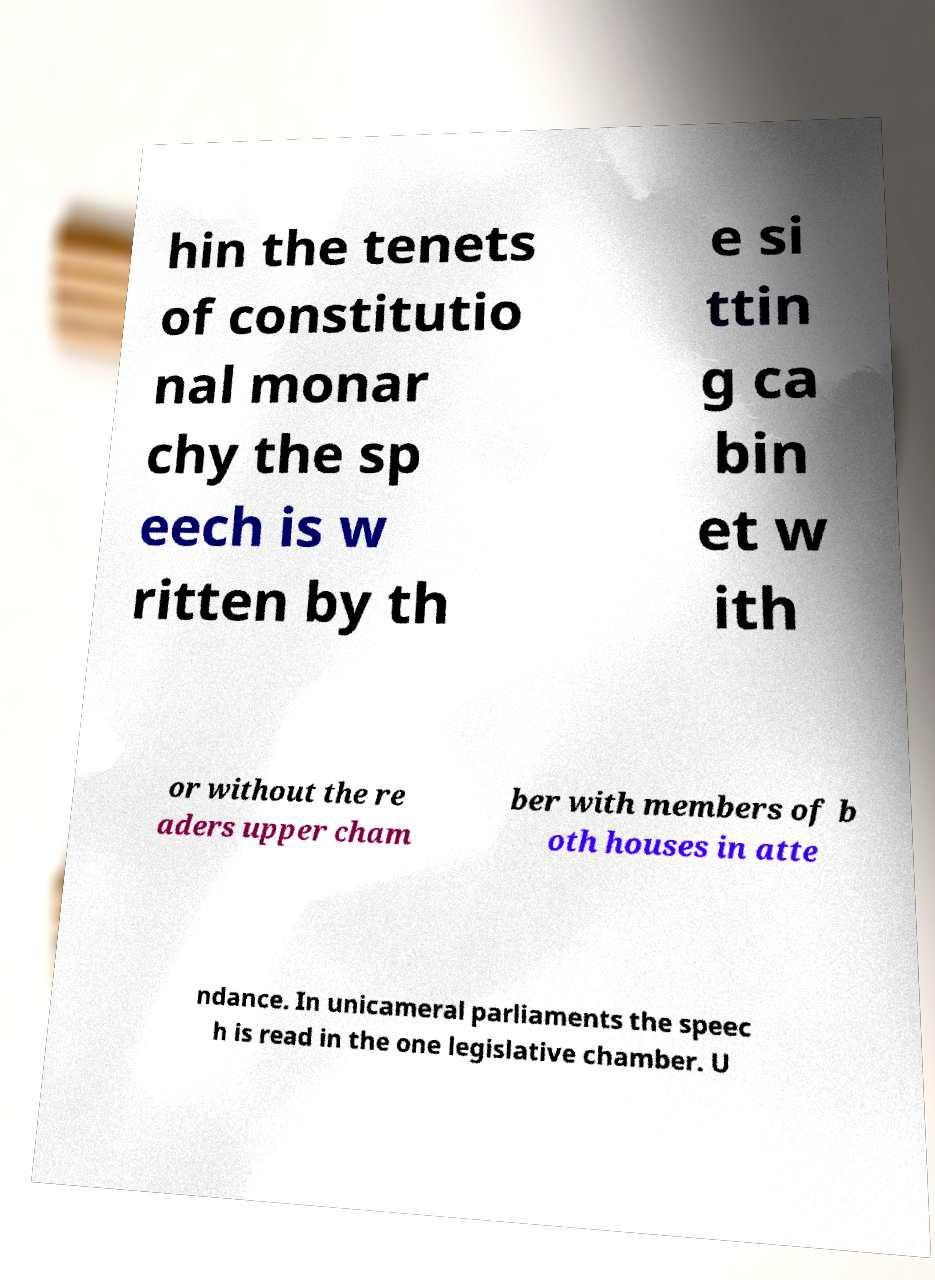Can you accurately transcribe the text from the provided image for me? hin the tenets of constitutio nal monar chy the sp eech is w ritten by th e si ttin g ca bin et w ith or without the re aders upper cham ber with members of b oth houses in atte ndance. In unicameral parliaments the speec h is read in the one legislative chamber. U 